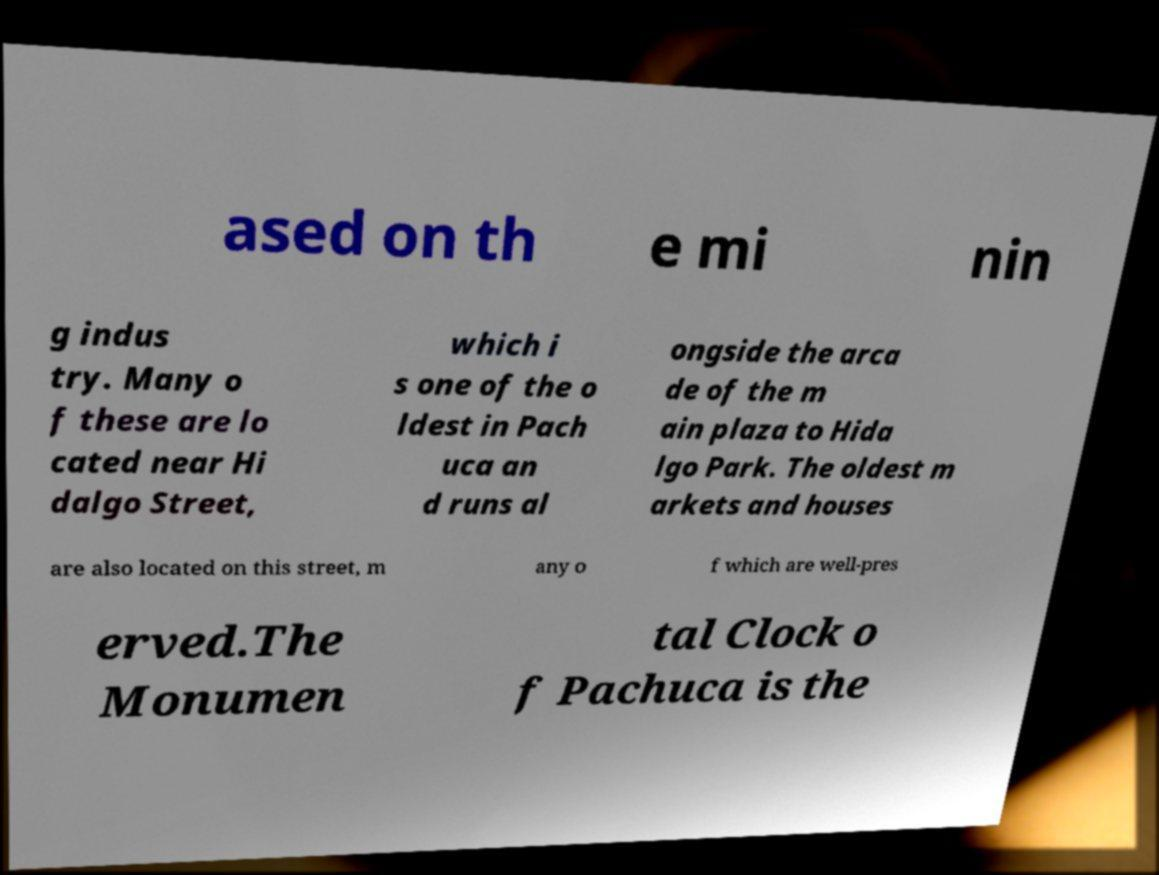Can you read and provide the text displayed in the image?This photo seems to have some interesting text. Can you extract and type it out for me? ased on th e mi nin g indus try. Many o f these are lo cated near Hi dalgo Street, which i s one of the o ldest in Pach uca an d runs al ongside the arca de of the m ain plaza to Hida lgo Park. The oldest m arkets and houses are also located on this street, m any o f which are well-pres erved.The Monumen tal Clock o f Pachuca is the 